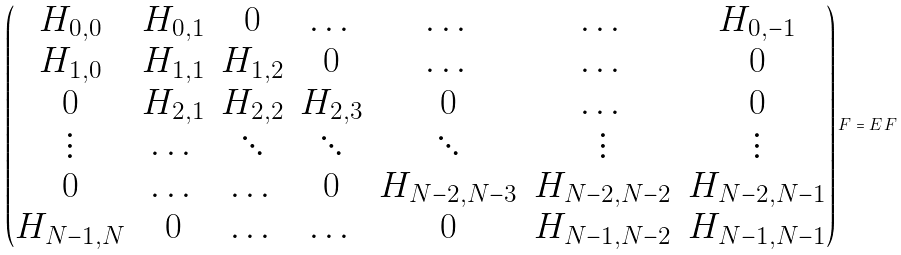Convert formula to latex. <formula><loc_0><loc_0><loc_500><loc_500>\begin{pmatrix} { H } _ { 0 , 0 } & { H } _ { 0 , 1 } & { 0 } & \dots & \dots & \dots & { H } _ { 0 , - 1 } \\ { H } _ { 1 , 0 } & { H } _ { 1 , 1 } & { H } _ { 1 , 2 } & { 0 } & \dots & \dots & { 0 } \\ { 0 } & { H } _ { 2 , 1 } & { H } _ { 2 , 2 } & { H } _ { 2 , 3 } & { 0 } & \dots & { 0 } \\ \vdots & \dots & \ddots & \ddots & \ddots & \vdots & \vdots \\ { 0 } & \dots & \dots & { 0 } & { H } _ { N - 2 , N - 3 } & { H } _ { N - 2 , N - 2 } & { H } _ { N - 2 , N - 1 } \\ { H } _ { N - 1 , N } & { 0 } & \dots & \dots & { 0 } & { H } _ { N - 1 , N - 2 } & { H } _ { N - 1 , N - 1 } \end{pmatrix} { F } = E \, { F }</formula> 